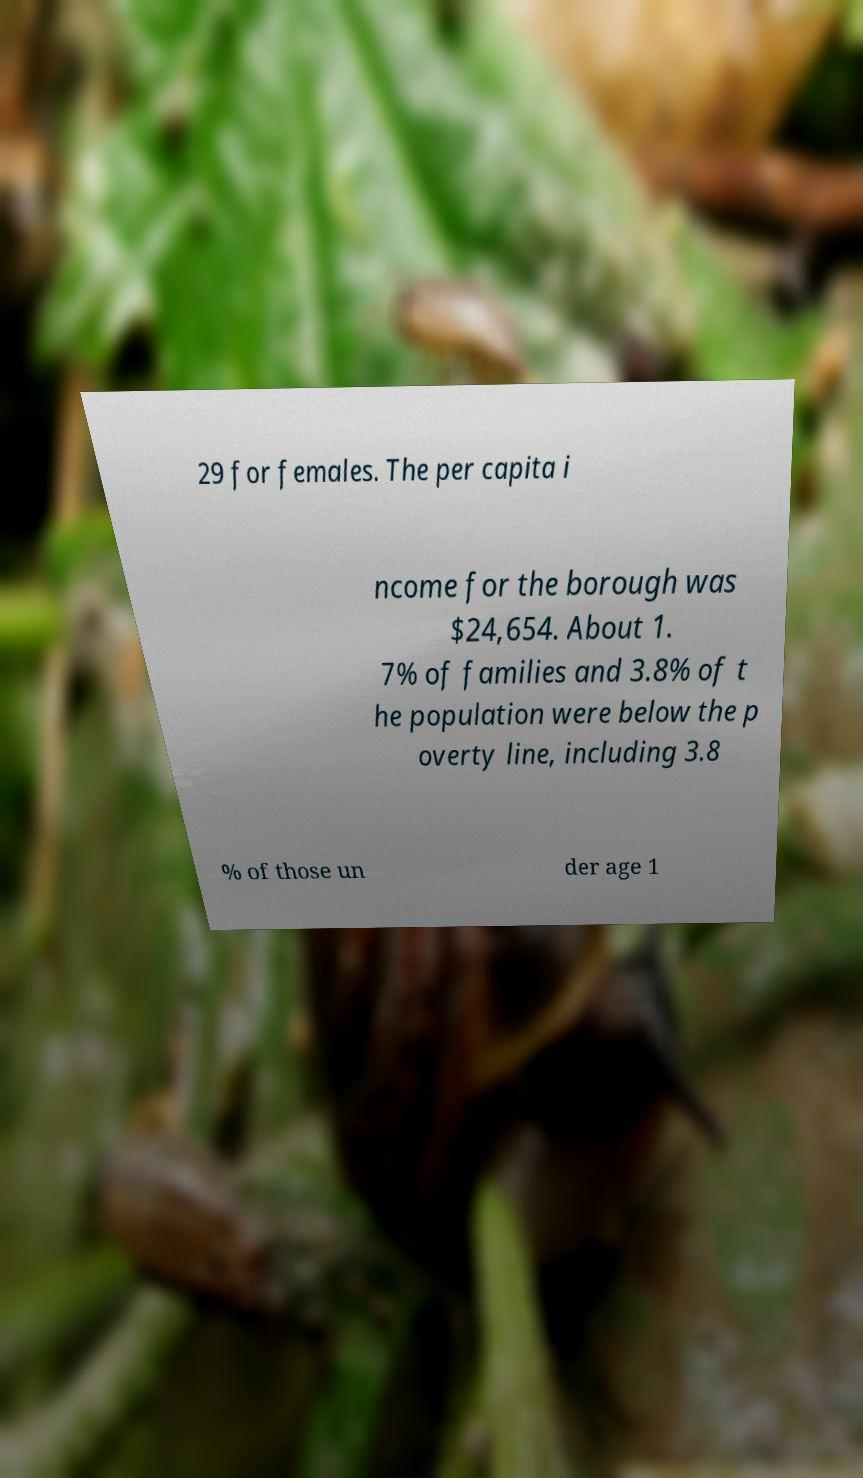Please identify and transcribe the text found in this image. 29 for females. The per capita i ncome for the borough was $24,654. About 1. 7% of families and 3.8% of t he population were below the p overty line, including 3.8 % of those un der age 1 